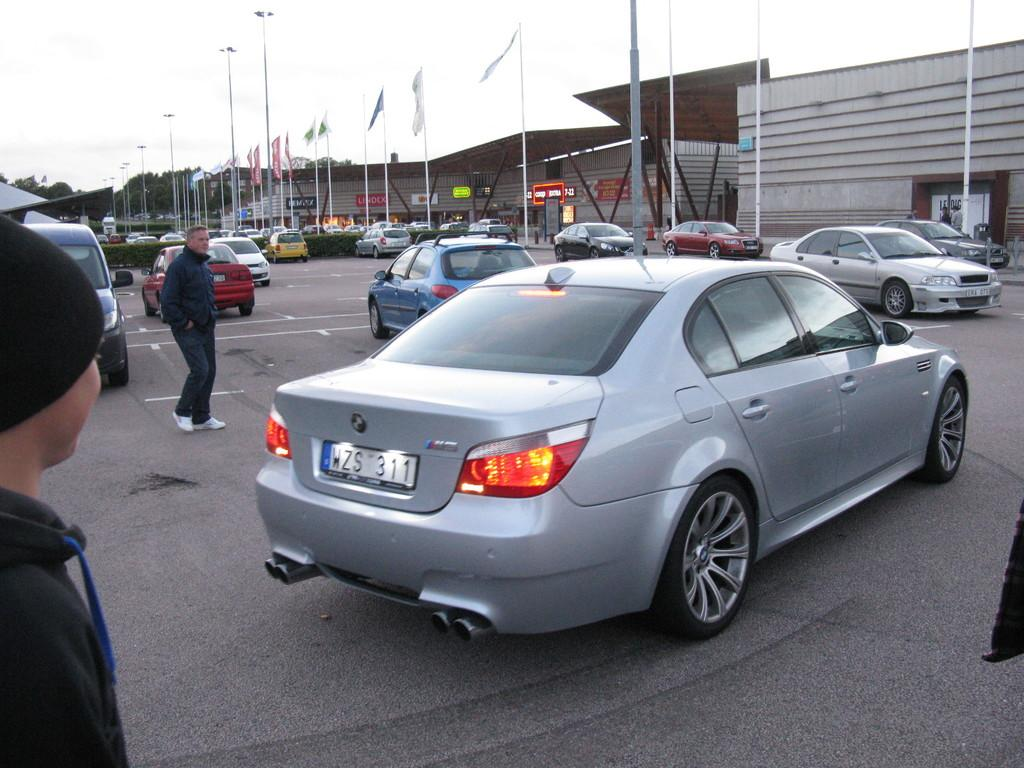<image>
Share a concise interpretation of the image provided. The silver car pulling away in the parking lot has the license plate numbers of WZS 311. 